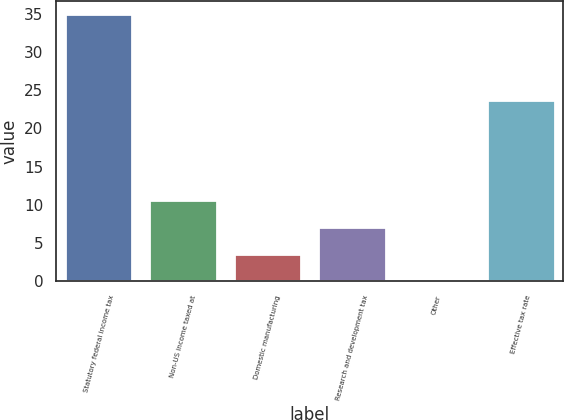Convert chart to OTSL. <chart><loc_0><loc_0><loc_500><loc_500><bar_chart><fcel>Statutory federal income tax<fcel>Non-US income taxed at<fcel>Domestic manufacturing<fcel>Research and development tax<fcel>Other<fcel>Effective tax rate<nl><fcel>35<fcel>10.57<fcel>3.59<fcel>7.08<fcel>0.1<fcel>23.7<nl></chart> 